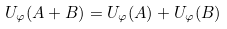<formula> <loc_0><loc_0><loc_500><loc_500>U _ { \varphi } ( A + B ) = U _ { \varphi } ( A ) + U _ { \varphi } ( B )</formula> 